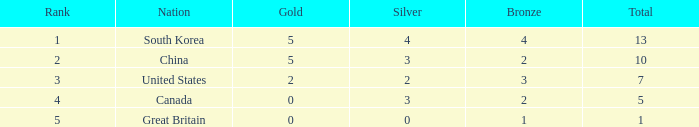What is the lowest Gold, when Nation is Canada, and when Rank is greater than 4? None. 